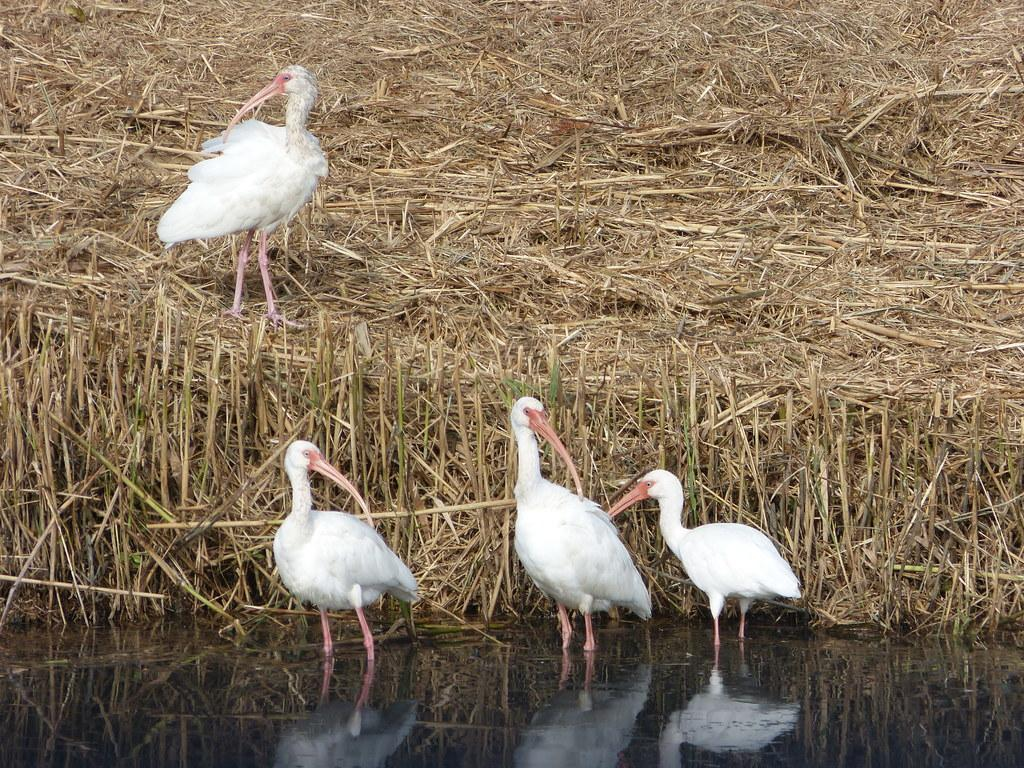What animals can be seen in the water in the image? There are birds standing in the water in the front of the image. What type of vegetation is visible in the background of the image? There is dry grass in the background of the image. Can you describe the bird in the background? There is a bird standing on the dry grass in the background. What type of agreement is being discussed by the boys in the image? There are no boys present in the image, and therefore no agreement is being discussed. 